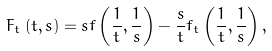<formula> <loc_0><loc_0><loc_500><loc_500>F _ { t } \left ( { t , s } \right ) = s f \left ( { \frac { 1 } { t } , \frac { 1 } { s } } \right ) - \frac { s } { t } f _ { t } \left ( { \frac { 1 } { t } , \frac { 1 } { s } } \right ) ,</formula> 